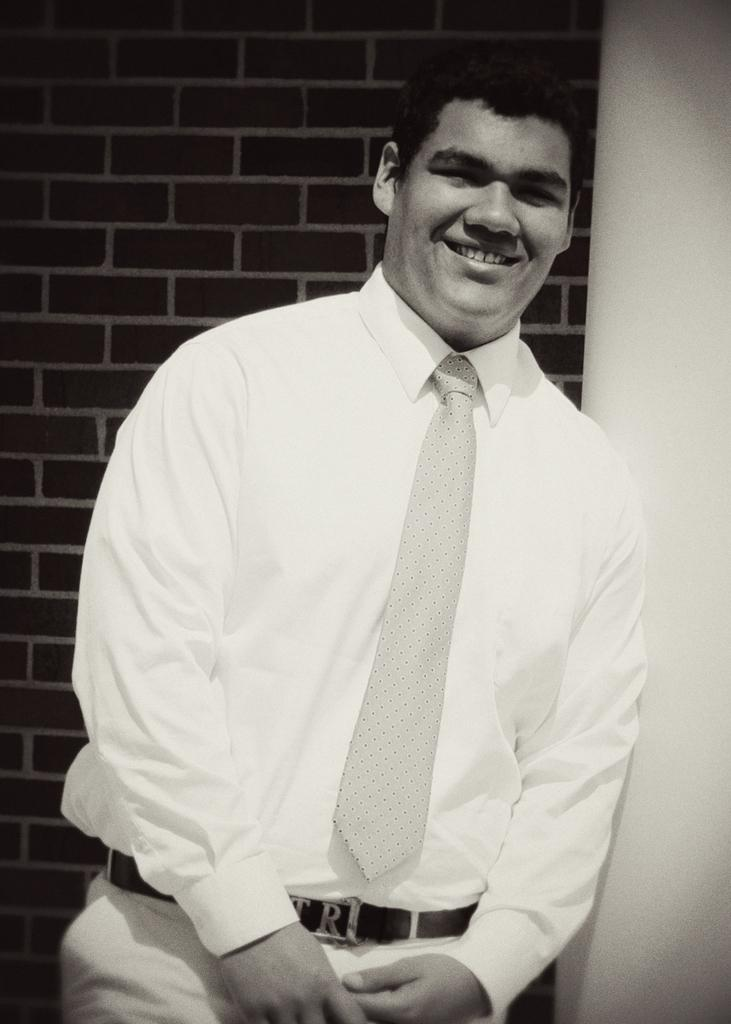What is there is a man in the image, what is he doing? The man in the image is standing. Can you describe the man's expression? The man is smiling. What can be seen in the background of the image? There is a wall in the background of the image. What type of circle is being drawn on the wall in the image? There is no circle being drawn on the wall in the image. What is the man doing with the wax in the image? There is no wax present in the image. 